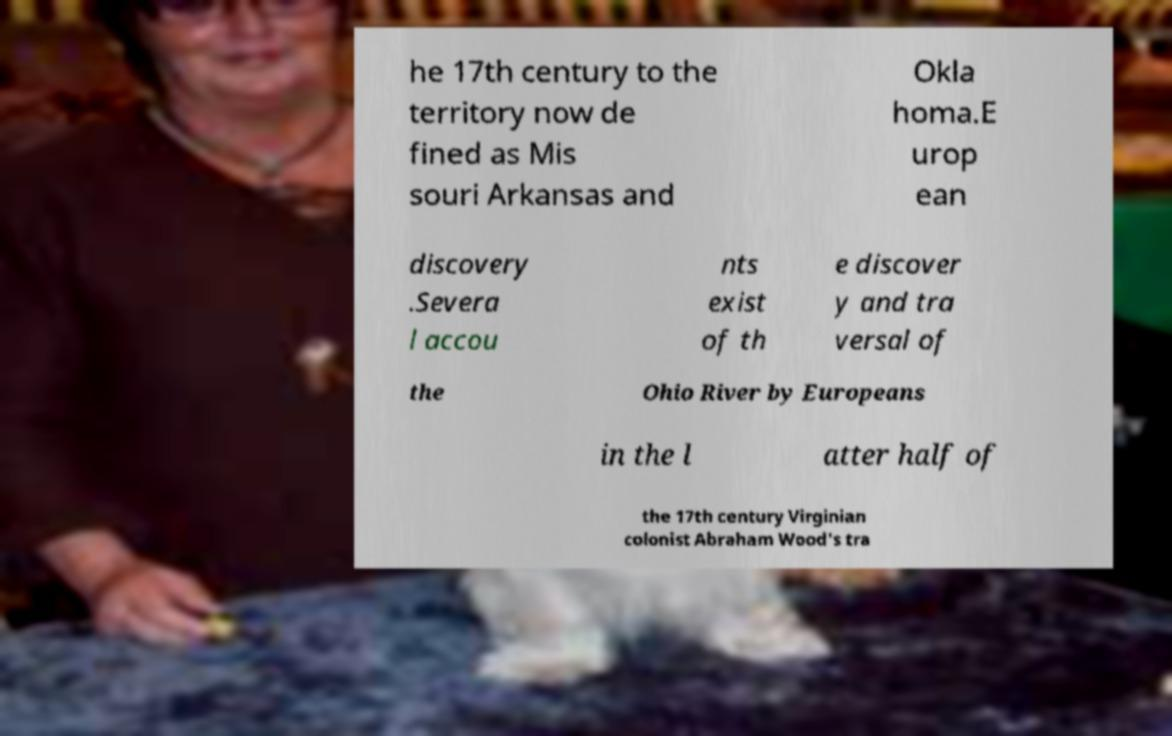There's text embedded in this image that I need extracted. Can you transcribe it verbatim? he 17th century to the territory now de fined as Mis souri Arkansas and Okla homa.E urop ean discovery .Severa l accou nts exist of th e discover y and tra versal of the Ohio River by Europeans in the l atter half of the 17th century Virginian colonist Abraham Wood's tra 